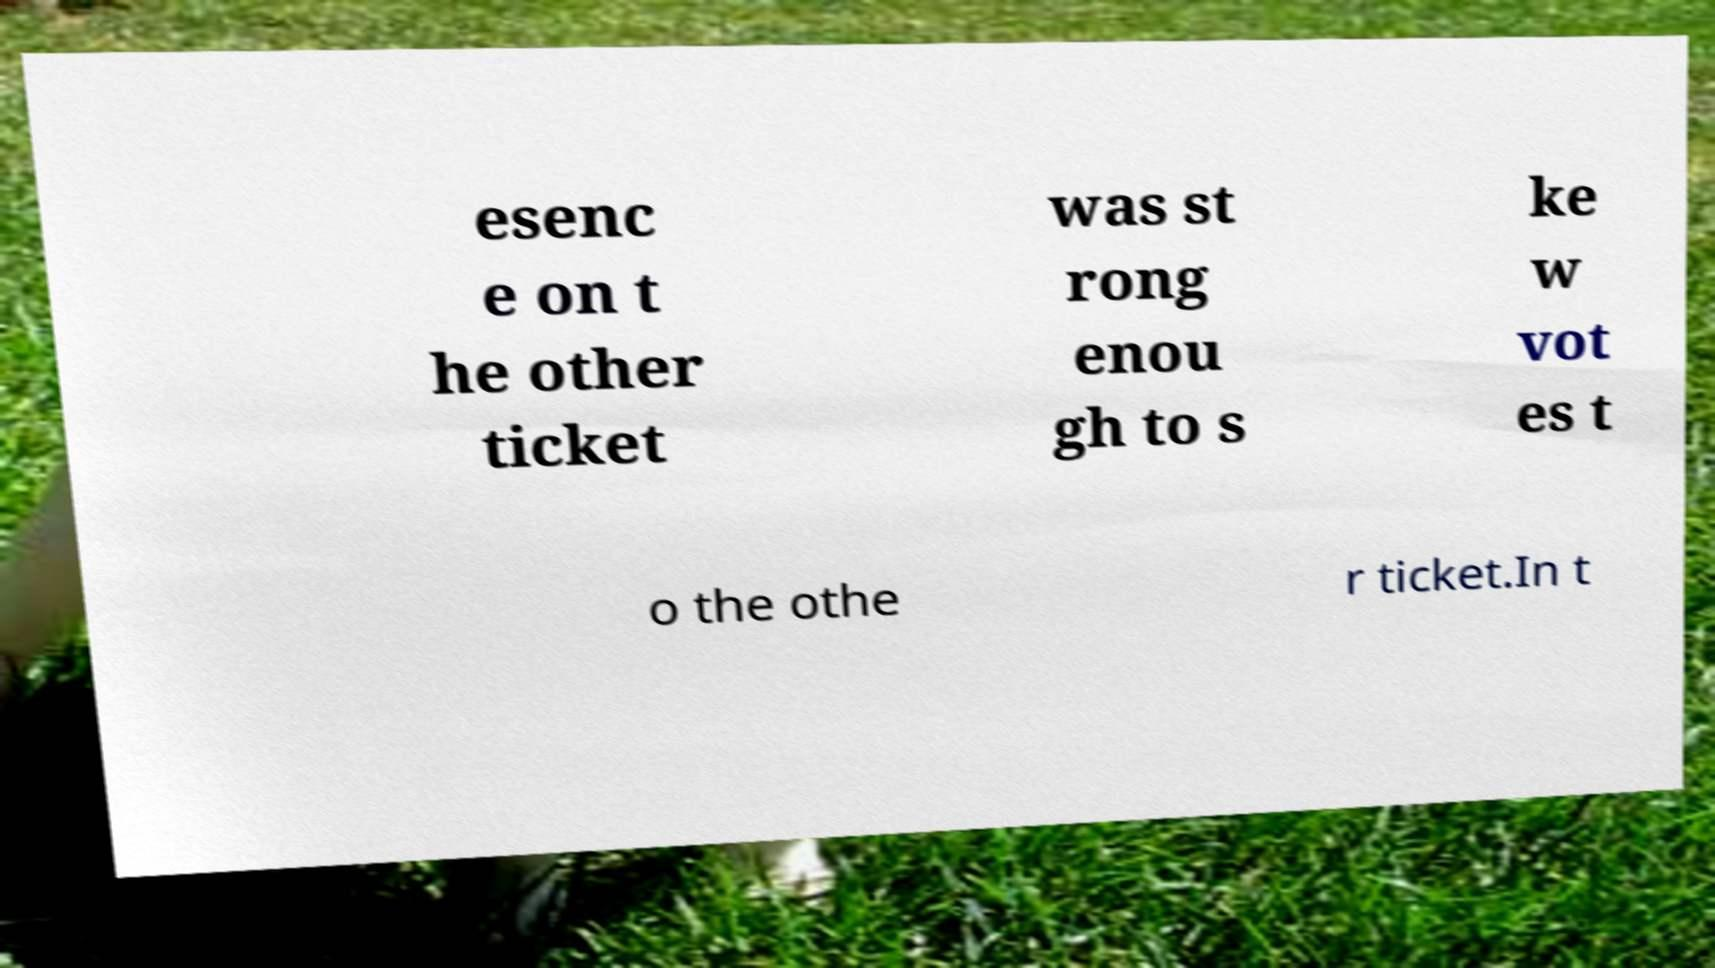Please identify and transcribe the text found in this image. esenc e on t he other ticket was st rong enou gh to s ke w vot es t o the othe r ticket.In t 